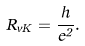<formula> <loc_0><loc_0><loc_500><loc_500>R _ { v K } = \frac { h } { e ^ { 2 } } .</formula> 